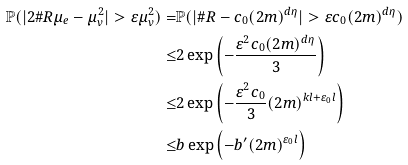<formula> <loc_0><loc_0><loc_500><loc_500>\mathbb { P } ( | 2 \# R \mu _ { e } - \mu _ { v } ^ { 2 } | > \varepsilon \mu _ { v } ^ { 2 } ) = & \mathbb { P } ( | \# R - c _ { 0 } ( 2 m ) ^ { d \eta } | > \varepsilon c _ { 0 } ( 2 m ) ^ { d \eta } ) \\ \leq & 2 \exp \left ( - \frac { \varepsilon ^ { 2 } c _ { 0 } ( 2 m ) ^ { d \eta } } { 3 } \right ) \\ \leq & 2 \exp \left ( - \frac { \varepsilon ^ { 2 } c _ { 0 } } { 3 } ( 2 m ) ^ { k l + \varepsilon _ { 0 } l } \right ) \\ \leq & b \exp \left ( - b ^ { \prime } ( 2 m ) ^ { \varepsilon _ { 0 } l } \right )</formula> 